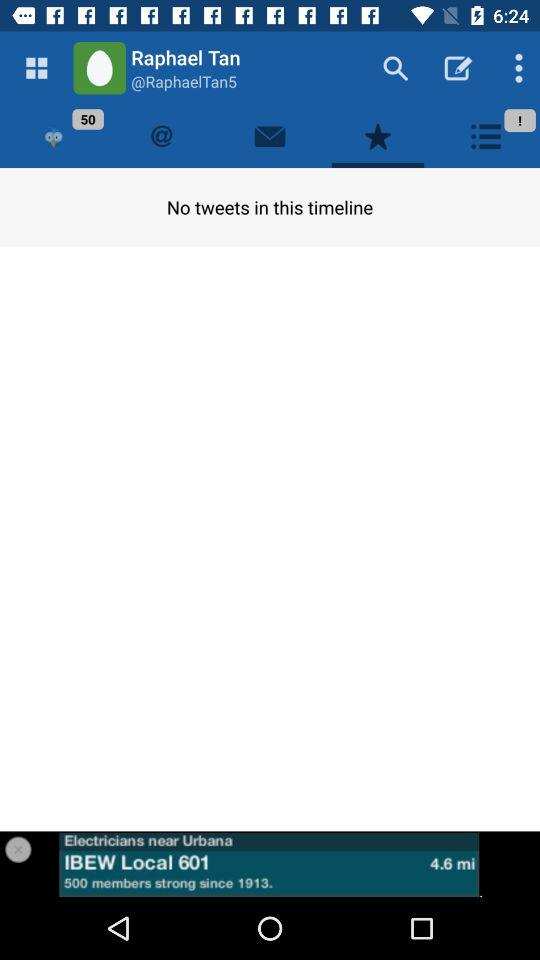What is the user name? The user name is Raphael Tan. 